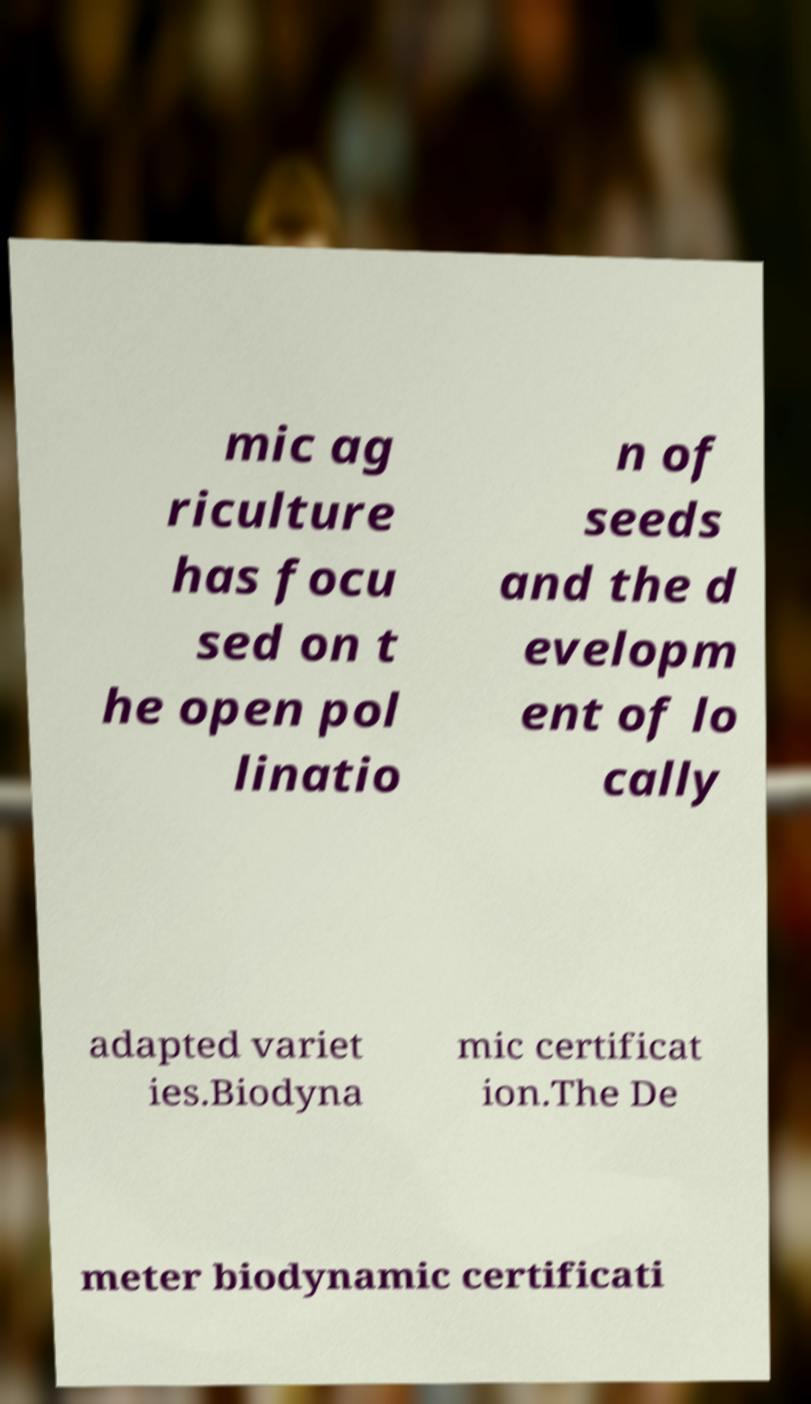Could you extract and type out the text from this image? mic ag riculture has focu sed on t he open pol linatio n of seeds and the d evelopm ent of lo cally adapted variet ies.Biodyna mic certificat ion.The De meter biodynamic certificati 